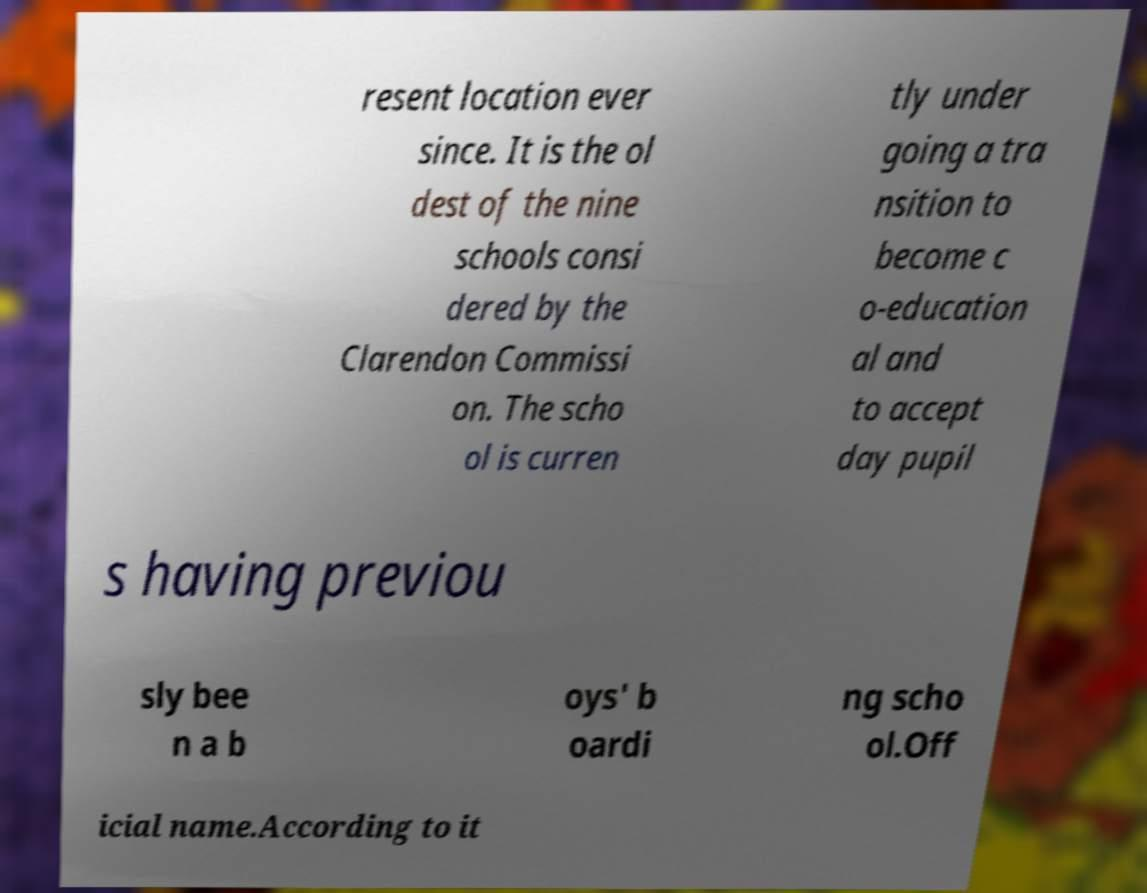Could you extract and type out the text from this image? resent location ever since. It is the ol dest of the nine schools consi dered by the Clarendon Commissi on. The scho ol is curren tly under going a tra nsition to become c o-education al and to accept day pupil s having previou sly bee n a b oys' b oardi ng scho ol.Off icial name.According to it 